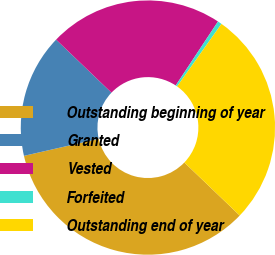Convert chart to OTSL. <chart><loc_0><loc_0><loc_500><loc_500><pie_chart><fcel>Outstanding beginning of year<fcel>Granted<fcel>Vested<fcel>Forfeited<fcel>Outstanding end of year<nl><fcel>34.27%<fcel>15.73%<fcel>22.13%<fcel>0.53%<fcel>27.33%<nl></chart> 